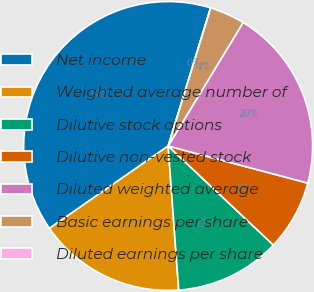Convert chart. <chart><loc_0><loc_0><loc_500><loc_500><pie_chart><fcel>Net income<fcel>Weighted average number of<fcel>Dilutive stock options<fcel>Dilutive non-vested stock<fcel>Diluted weighted average<fcel>Basic earnings per share<fcel>Diluted earnings per share<nl><fcel>39.4%<fcel>16.51%<fcel>11.82%<fcel>7.88%<fcel>20.45%<fcel>3.94%<fcel>0.0%<nl></chart> 